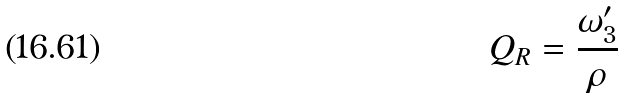Convert formula to latex. <formula><loc_0><loc_0><loc_500><loc_500>Q _ { R } = \frac { \omega _ { 3 } ^ { \prime } } { \rho }</formula> 